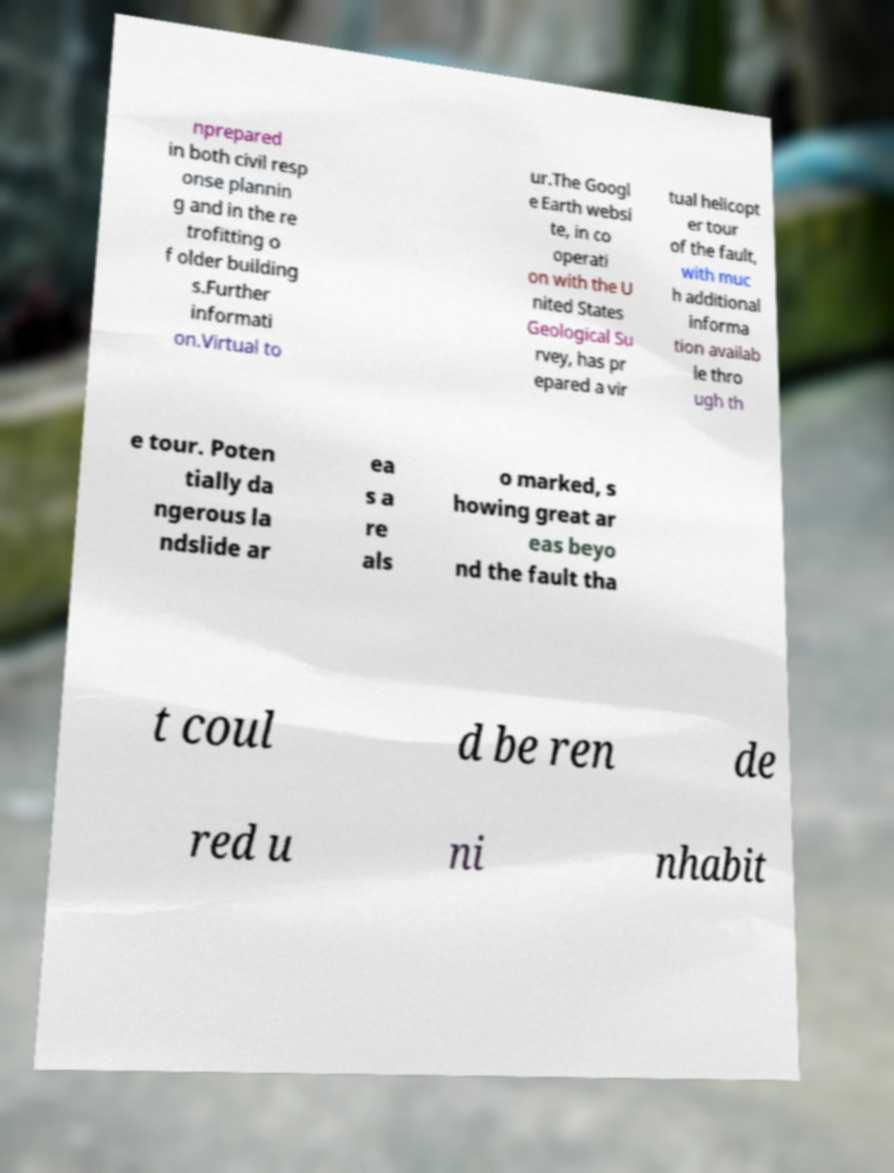Please identify and transcribe the text found in this image. nprepared in both civil resp onse plannin g and in the re trofitting o f older building s.Further informati on.Virtual to ur.The Googl e Earth websi te, in co operati on with the U nited States Geological Su rvey, has pr epared a vir tual helicopt er tour of the fault, with muc h additional informa tion availab le thro ugh th e tour. Poten tially da ngerous la ndslide ar ea s a re als o marked, s howing great ar eas beyo nd the fault tha t coul d be ren de red u ni nhabit 